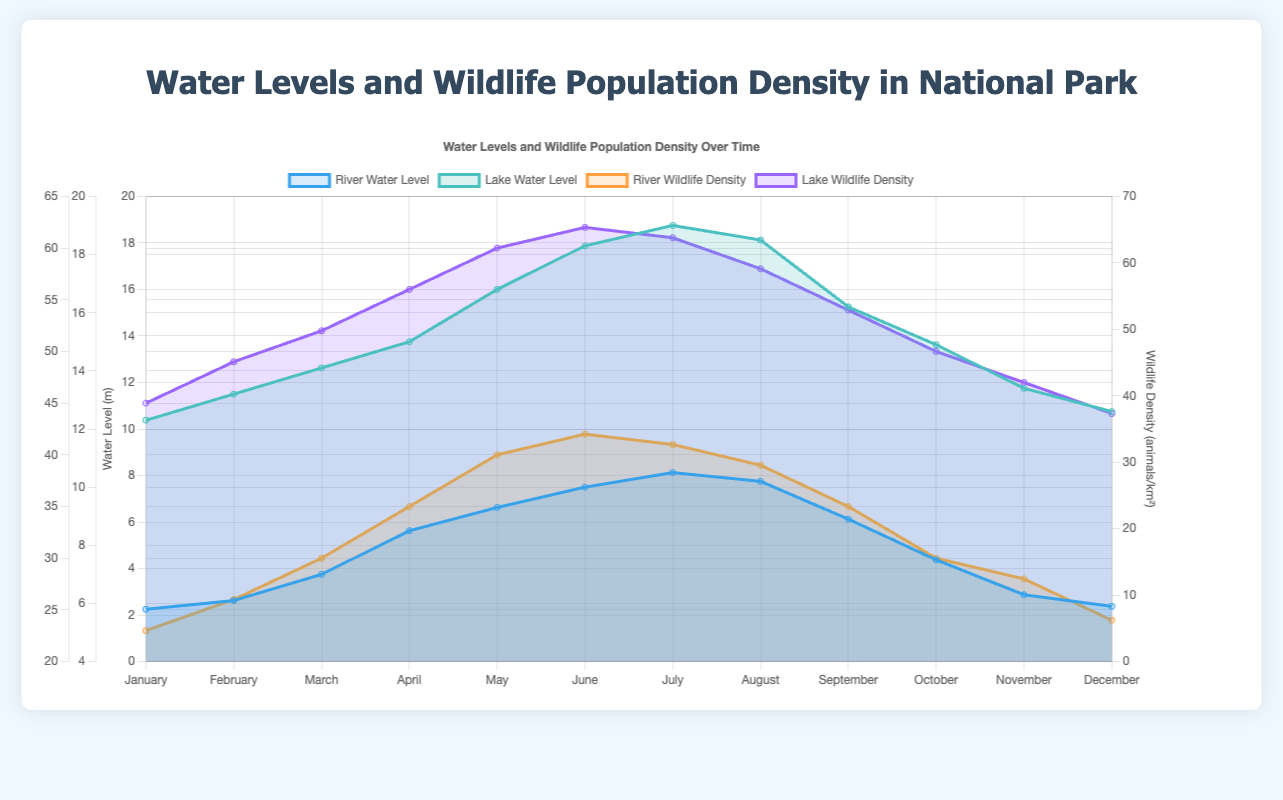What is the title of the chart? The title of the chart is prominently displayed at the top, indicating the overall theme of the visualization.
Answer: Water Levels and Wildlife Population Density in National Park Which water body has higher water levels in January? By observing both river and lake water levels in January, it's clear which one has the higher value. The lake water level is 12.3 and the river water level is 5.8.
Answer: lake Which month has the highest river water level? Follow the river water level data points along the x-axis, and find the maximum value. The highest river water level of 10.5 occurs in July.
Answer: July What's the average wildlife density in the lake over the year? Sum all the lake wildlife density values and divide by the number of months. The calculation is (45+49+52+56+60+62+61+58+54+50+47+44) / 12 = 53.
Answer: 53 In which month is the river wildlife density the highest? Look through the river wildlife density values month by month and identify the maximum. The highest value of 42 occurs in June.
Answer: June How does lake wildlife density in April compare to September? Compare the lake wildlife density values for April and September. In April, it's 56, and in September, it's 54.
Answer: higher in April Does the river wildlife density increase in the first half of the year? Check the trend for river wildlife density values from January to June (23 to 42). The values mostly increase.
Answer: Yes What is the difference between the highest and lowest lake water levels? Subtract the lowest lake water level (12.3 in January) from the highest lake water level (19.0 in July). The difference is 19.0 - 12.3 = 6.7.
Answer: 6.7 When do water levels for both the river and lake peak? Find the months with the maximum values for both water levels. The river peaks at 10.5 in July and the lake peaks at 19.0 in July.
Answer: July Is there any month when the river wildlife density is higher than the lake wildlife density? Compare the monthly values of river and lake wildlife densities across all months. The river wildlife density is never higher than the lake wildlife density.
Answer: No 